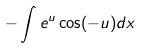Convert formula to latex. <formula><loc_0><loc_0><loc_500><loc_500>- \int e ^ { u } \cos ( - u ) d x</formula> 